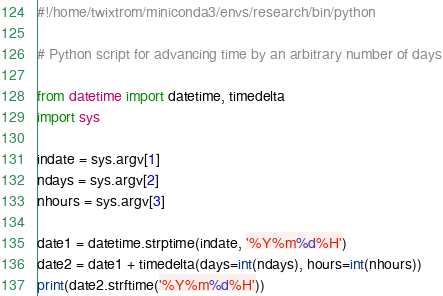Convert code to text. <code><loc_0><loc_0><loc_500><loc_500><_Python_>#!/home/twixtrom/miniconda3/envs/research/bin/python

# Python script for advancing time by an arbitrary number of days

from datetime import datetime, timedelta
import sys

indate = sys.argv[1]
ndays = sys.argv[2]
nhours = sys.argv[3]

date1 = datetime.strptime(indate, '%Y%m%d%H')
date2 = date1 + timedelta(days=int(ndays), hours=int(nhours))
print(date2.strftime('%Y%m%d%H'))
</code> 